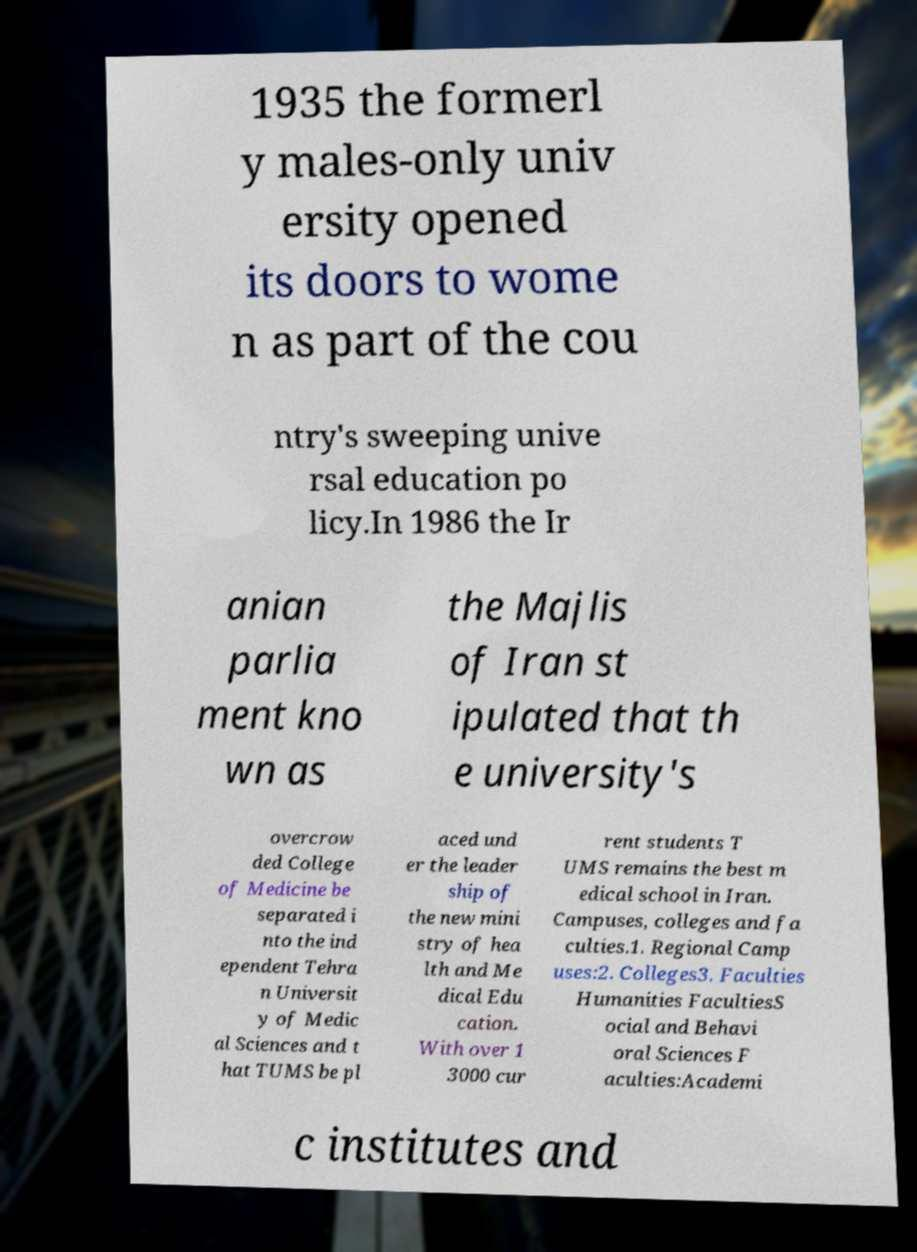What messages or text are displayed in this image? I need them in a readable, typed format. 1935 the formerl y males-only univ ersity opened its doors to wome n as part of the cou ntry's sweeping unive rsal education po licy.In 1986 the Ir anian parlia ment kno wn as the Majlis of Iran st ipulated that th e university's overcrow ded College of Medicine be separated i nto the ind ependent Tehra n Universit y of Medic al Sciences and t hat TUMS be pl aced und er the leader ship of the new mini stry of hea lth and Me dical Edu cation. With over 1 3000 cur rent students T UMS remains the best m edical school in Iran. Campuses, colleges and fa culties.1. Regional Camp uses:2. Colleges3. Faculties Humanities FacultiesS ocial and Behavi oral Sciences F aculties:Academi c institutes and 